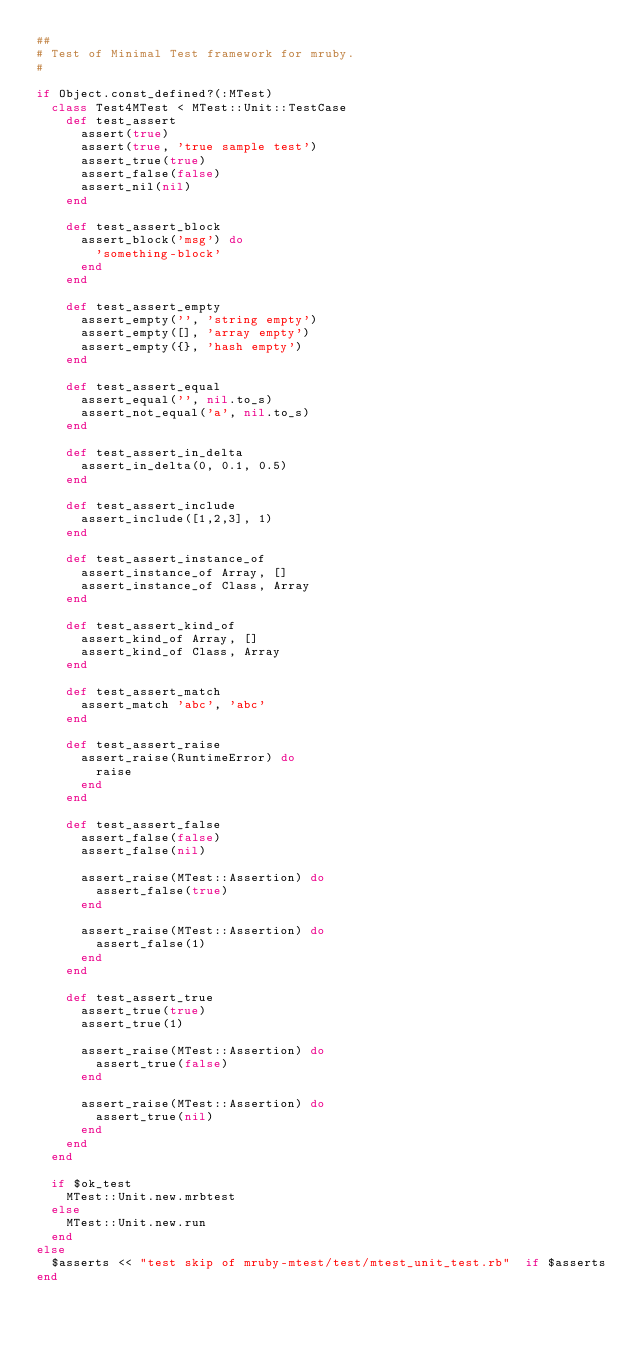Convert code to text. <code><loc_0><loc_0><loc_500><loc_500><_Ruby_>##
# Test of Minimal Test framework for mruby.
#

if Object.const_defined?(:MTest)
  class Test4MTest < MTest::Unit::TestCase
    def test_assert
      assert(true)
      assert(true, 'true sample test')
      assert_true(true)
      assert_false(false)
      assert_nil(nil)
    end

    def test_assert_block
      assert_block('msg') do
        'something-block'
      end
    end

    def test_assert_empty
      assert_empty('', 'string empty')
      assert_empty([], 'array empty')
      assert_empty({}, 'hash empty')
    end

    def test_assert_equal
      assert_equal('', nil.to_s)
      assert_not_equal('a', nil.to_s)
    end

    def test_assert_in_delta
      assert_in_delta(0, 0.1, 0.5)
    end

    def test_assert_include
      assert_include([1,2,3], 1)
    end

    def test_assert_instance_of
      assert_instance_of Array, []
      assert_instance_of Class, Array
    end

    def test_assert_kind_of
      assert_kind_of Array, []
      assert_kind_of Class, Array
    end

    def test_assert_match
      assert_match 'abc', 'abc'
    end

    def test_assert_raise
      assert_raise(RuntimeError) do
        raise
      end
    end

    def test_assert_false
      assert_false(false)
      assert_false(nil)

      assert_raise(MTest::Assertion) do
        assert_false(true)
      end

      assert_raise(MTest::Assertion) do
        assert_false(1)
      end
    end

    def test_assert_true
      assert_true(true)
      assert_true(1)

      assert_raise(MTest::Assertion) do
        assert_true(false)
      end

      assert_raise(MTest::Assertion) do
        assert_true(nil)
      end
    end
  end

  if $ok_test
    MTest::Unit.new.mrbtest
  else
    MTest::Unit.new.run
  end
else
  $asserts << "test skip of mruby-mtest/test/mtest_unit_test.rb"  if $asserts
end
</code> 